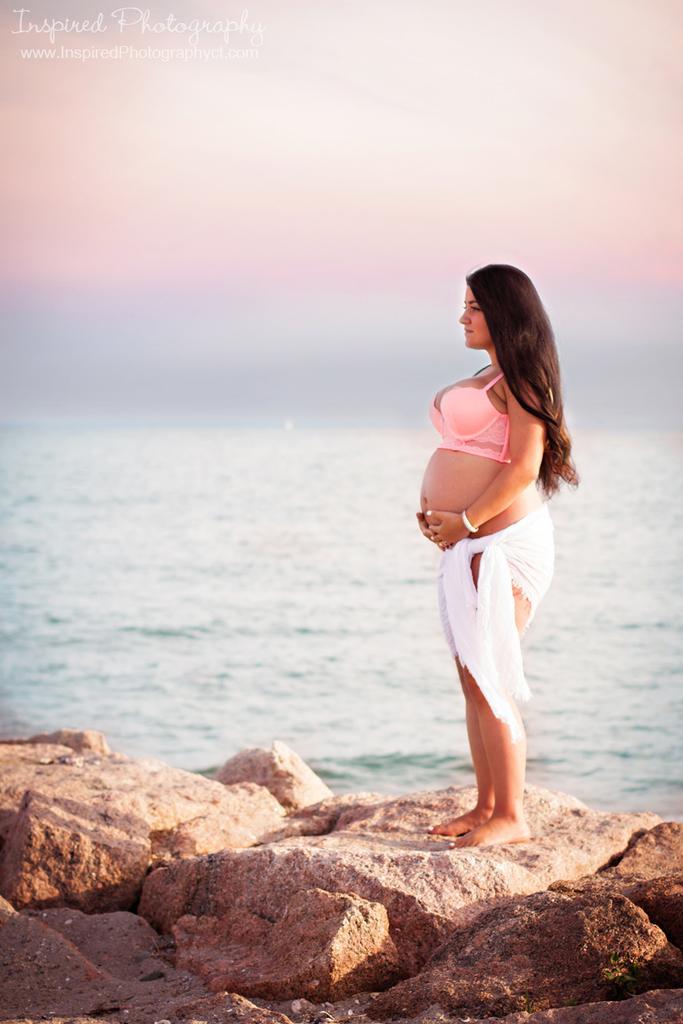How would you summarize this image in a sentence or two? A woman is standing, she wore pink color top and white color cloth. This is the water. 